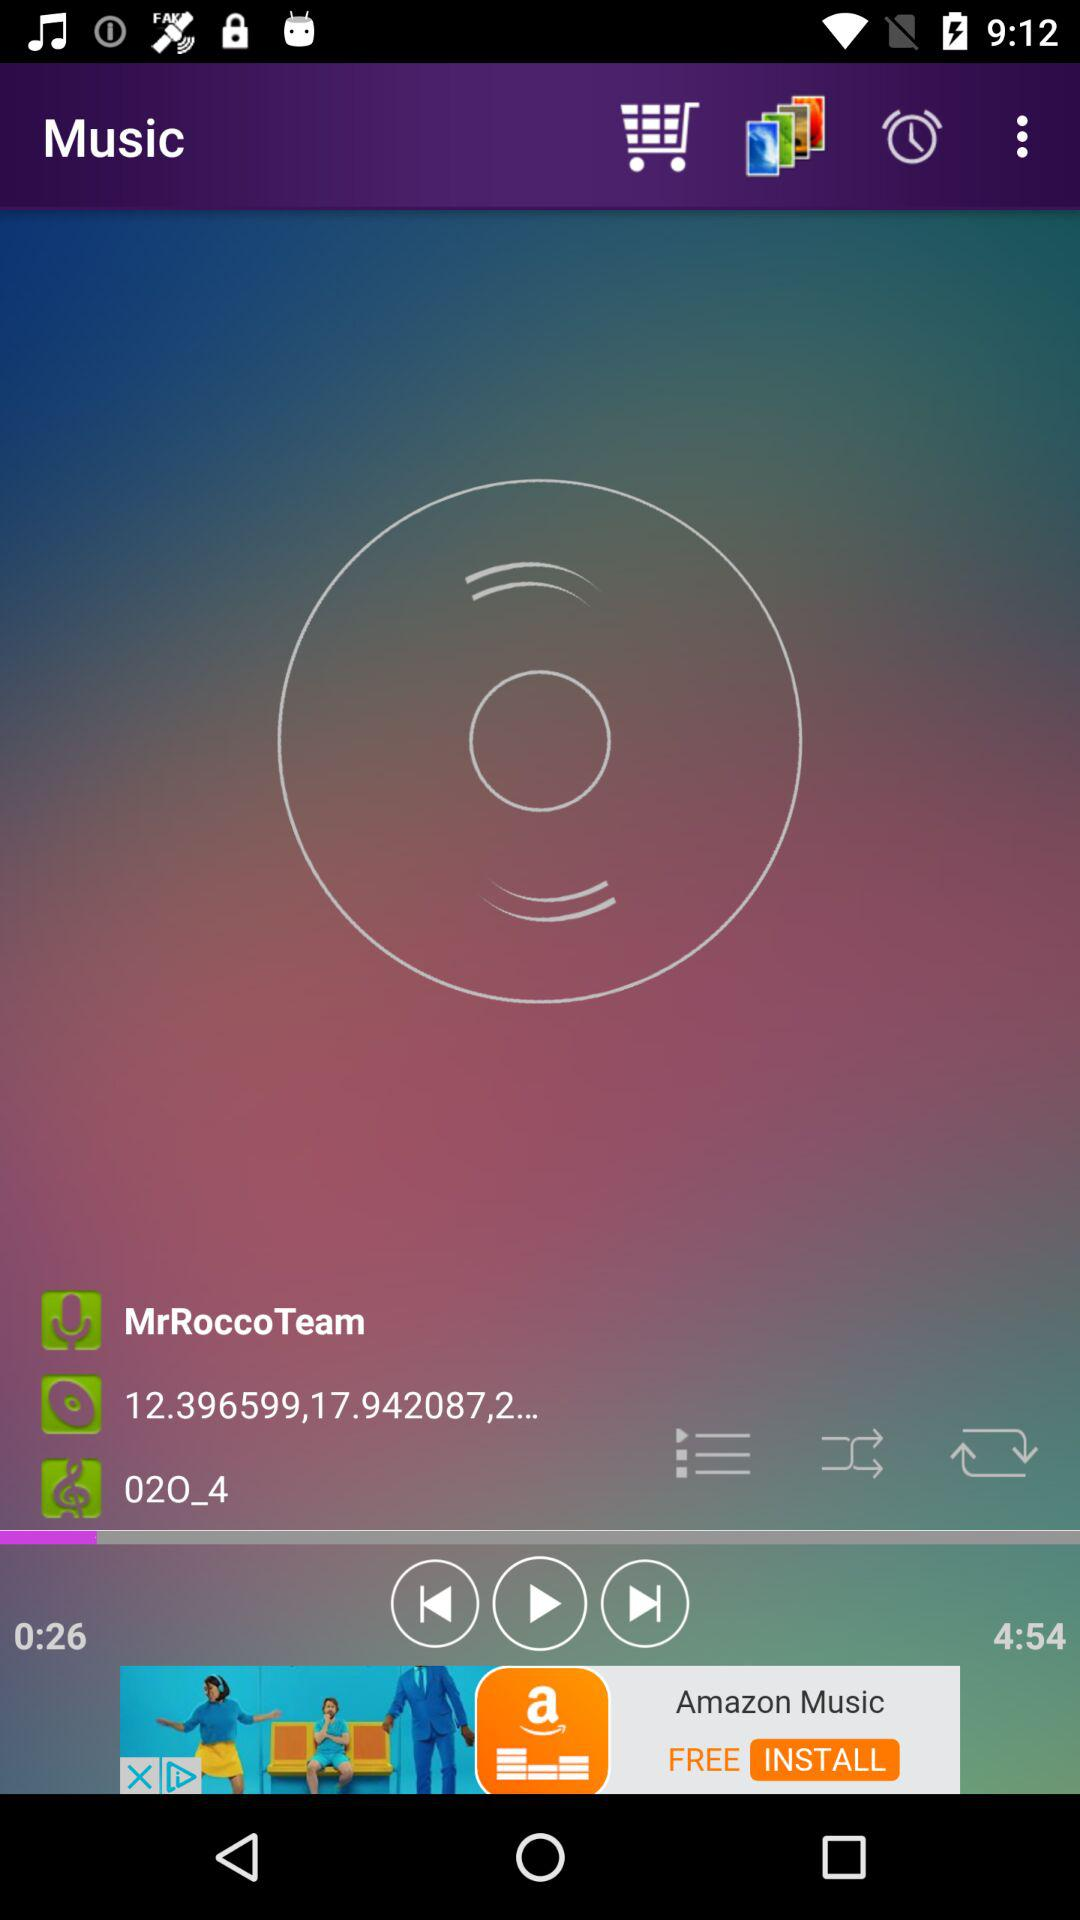What is the duration of the audio? The duration of the audio is 4 minutes 54 seconds. 